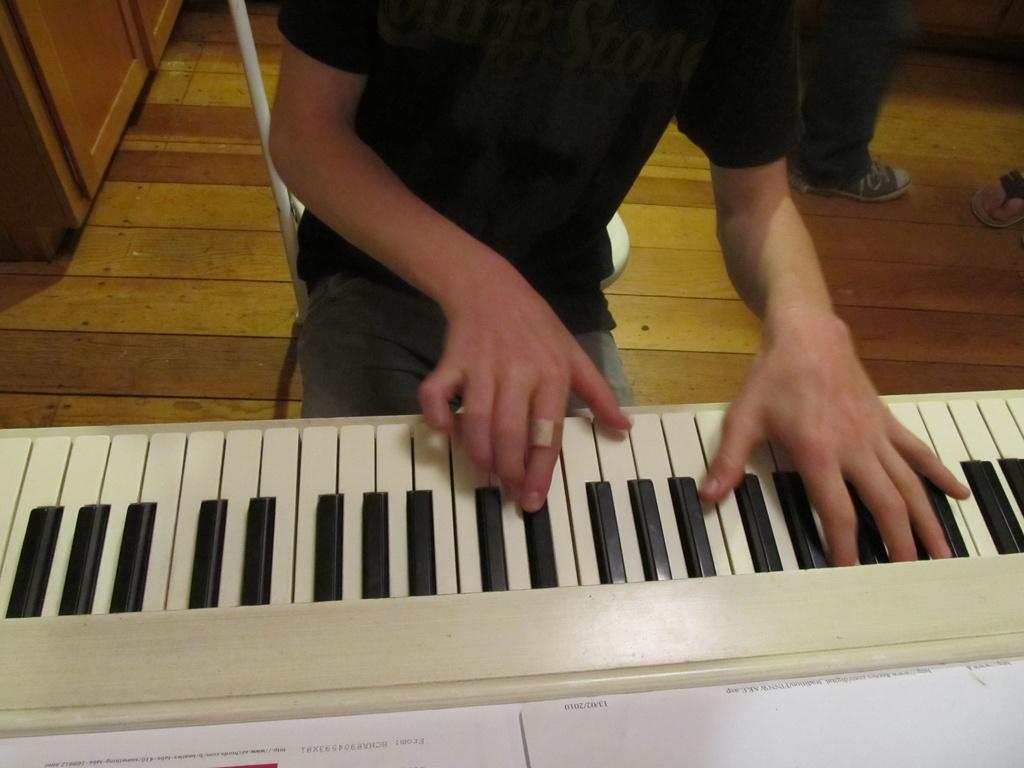Describe this image in one or two sentences. a person is playing keyboard. behind him there are legs of 2 other persons. 